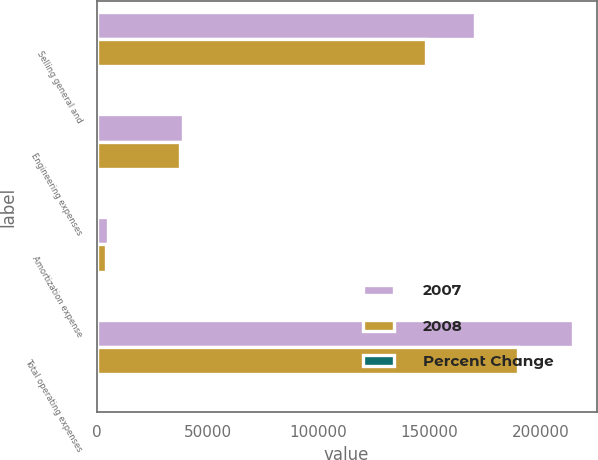Convert chart to OTSL. <chart><loc_0><loc_0><loc_500><loc_500><stacked_bar_chart><ecel><fcel>Selling general and<fcel>Engineering expenses<fcel>Amortization expense<fcel>Total operating expenses<nl><fcel>2007<fcel>170597<fcel>38981<fcel>5092<fcel>214670<nl><fcel>2008<fcel>148437<fcel>37434<fcel>4007<fcel>189878<nl><fcel>Percent Change<fcel>14.9<fcel>4.1<fcel>27.1<fcel>13.1<nl></chart> 